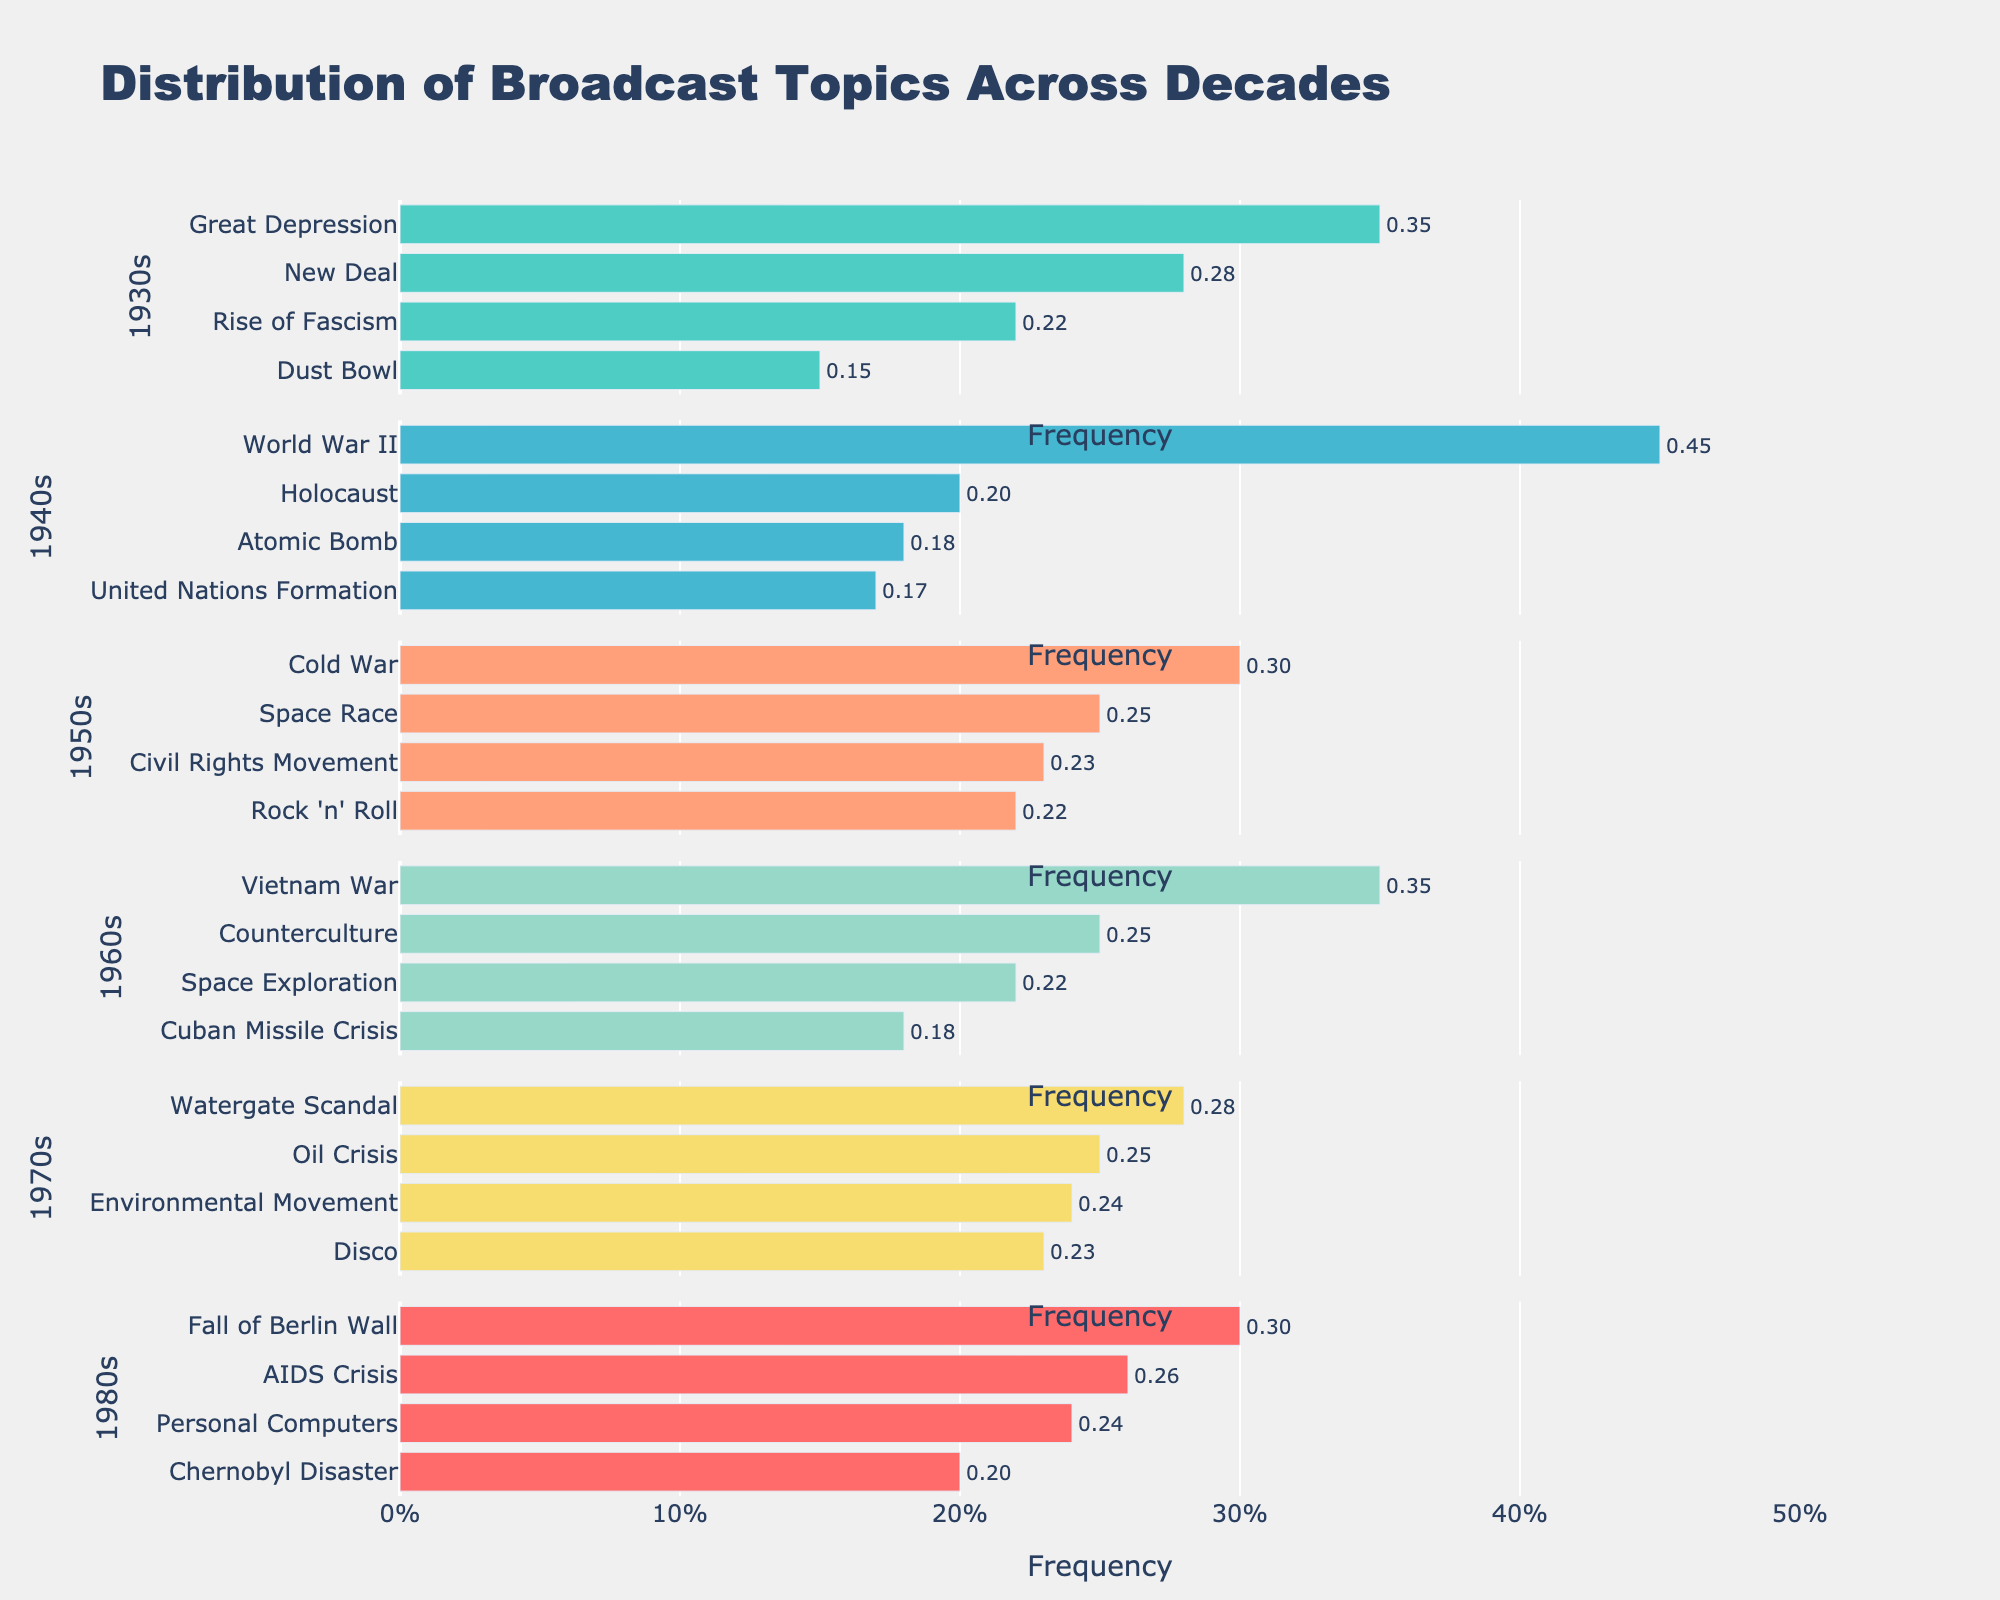What's the most frequent broadcast topic in the 1940s? Observe the horizontal bars for the 1940s decade; the longest bar represents the most frequent topic. "World War II" has the longest bar with a frequency of 0.45.
Answer: World War II Which decade had the highest frequency of broadcasts about space-related topics? Compare the frequencies of space-related topics across different decades. The 1960s show higher combined frequencies for "Space Exploration" (0.22) and "Space Race" (0.25) totaling 0.47 compared with 0.25 in the 1950s for "Space Race" alone.
Answer: 1960s What is the combined frequency of the Civil Rights Movement and Rock 'n' Roll broadcasts in the 1950s? Add the frequencies of "Civil Rights Movement" and "Rock 'n' Roll" in the 1950s. The values are 0.23 and 0.22 respectively, summing to 0.45.
Answer: 0.45 How did the focus on environmental issues evolve between the 1970s and the 1980s? Compare the frequency of environmental topics for these decades. "Environmental Movement" in the 1970s has a frequency of 0.24 whereas there are no explicitly environmental topics listed for the 1980s.
Answer: Decreased Which decade had the most varied set of broadcast topics based on the given data? Evaluate the number of discrete topics listed for each decade. Each decade has 4 topics, but the variation can be measured by the range of frequencies. The 1950s have topics ranging from 0.22 to 0.30, showing relatively high variation.
Answer: 1950s Among the provided decades, which single topic had the lowest frequency in its decade? Identify the smallest frequency value in each decade and compare them. "Dust Bowl" in the 1930s has the lowest frequency at 0.15 across all the given decades.
Answer: Dust Bowl Which decade has the smallest representation of any single topic above 0.20 frequency? Identify decades with topics having frequencies greater than 0.20 and find the one with the fewest such topics. The 1930s have 2 topics above 0.20; other decades have at least 3.
Answer: 1930s What percentage of the total broadcasts in the 1980s did the AIDS Crisis and Chernobyl Disaster account for? Add the frequencies for "AIDS Crisis" (0.26) and "Chernobyl Disaster" (0.20) then convert to percentage: (0.26 + 0.20) * 100 = 46%.
Answer: 46% Which decade has the most balanced distribution of topics in terms of frequency? Evaluate the range and variance of topic frequencies for each decade. The 1970s have values relatively close to each other (0.23 to 0.28), indicating a balanced distribution.
Answer: 1970s 